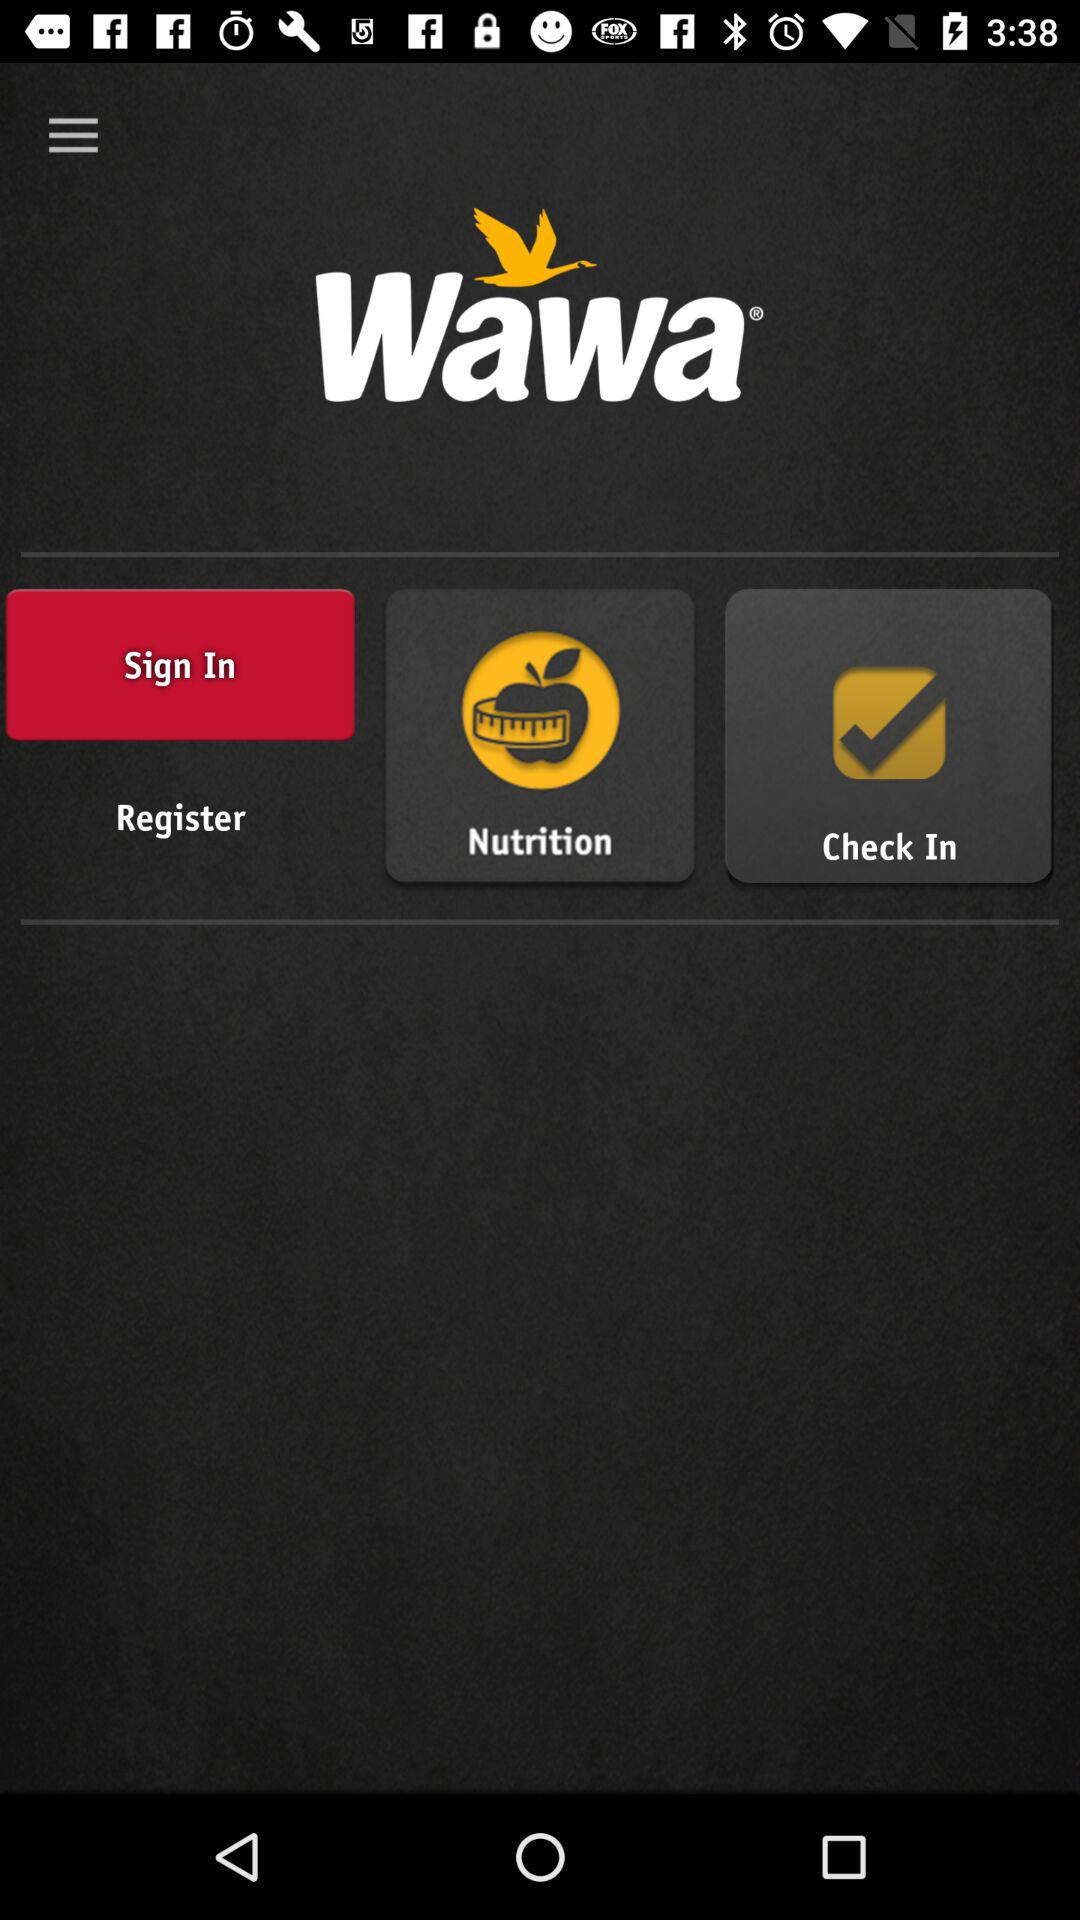Which health statistics are stored in "Nutrition"?
When the provided information is insufficient, respond with <no answer>. <no answer> 